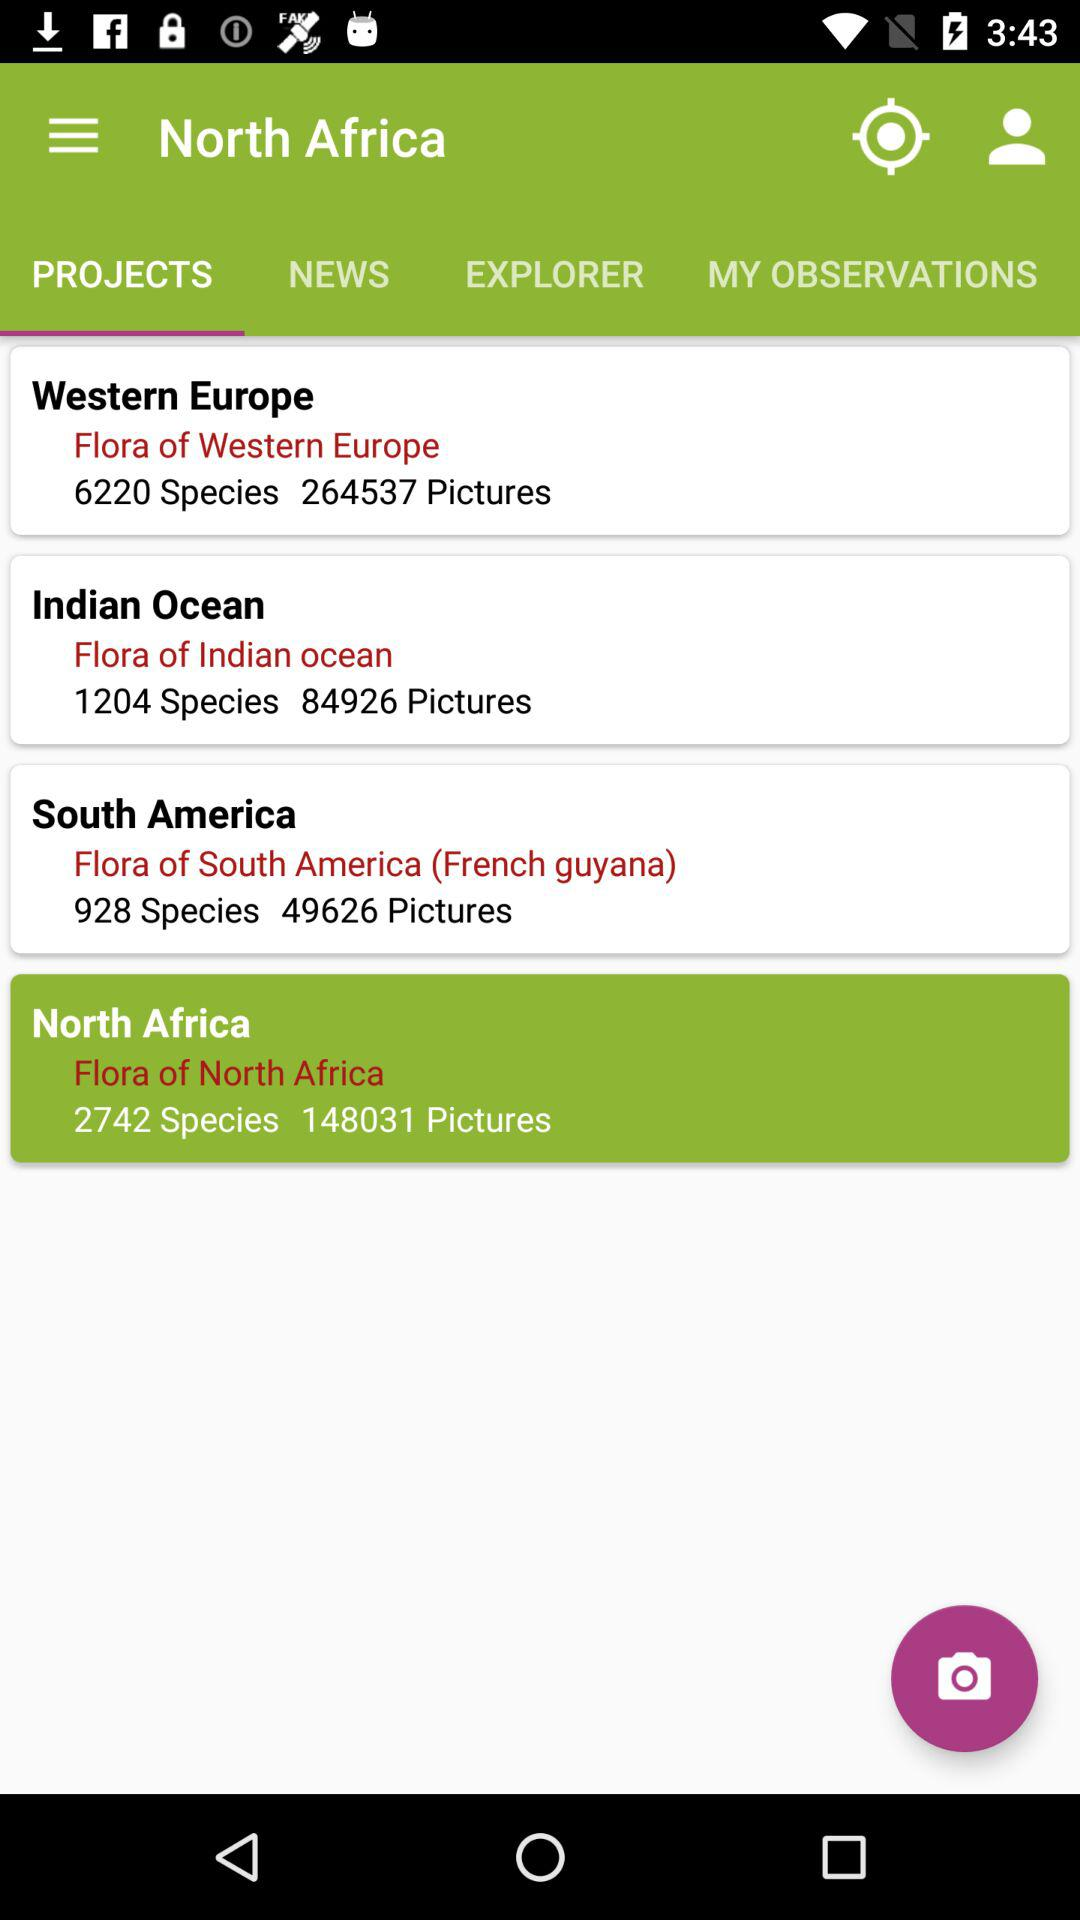What's the total number of species in the "Flora of Western Europe"? The total number of species in the "Flora of Western Europe" is 6220. 